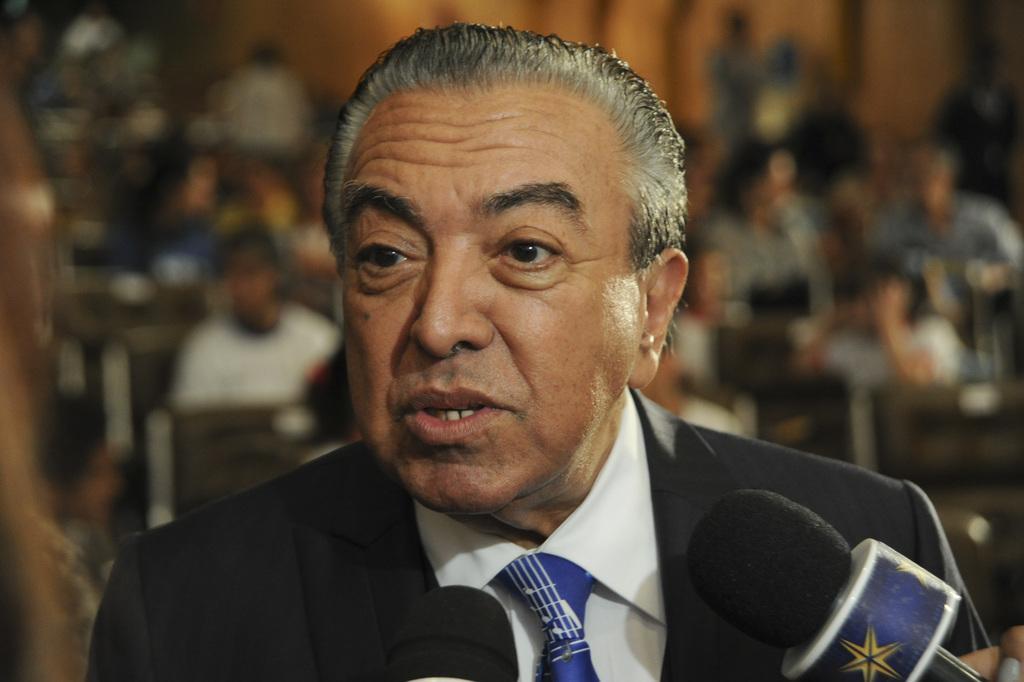Could you give a brief overview of what you see in this image? In this image I can see a person and the person is wearing black blazer, white shirt and blue color tie and I can also see a microphone and I can see blurred background. 